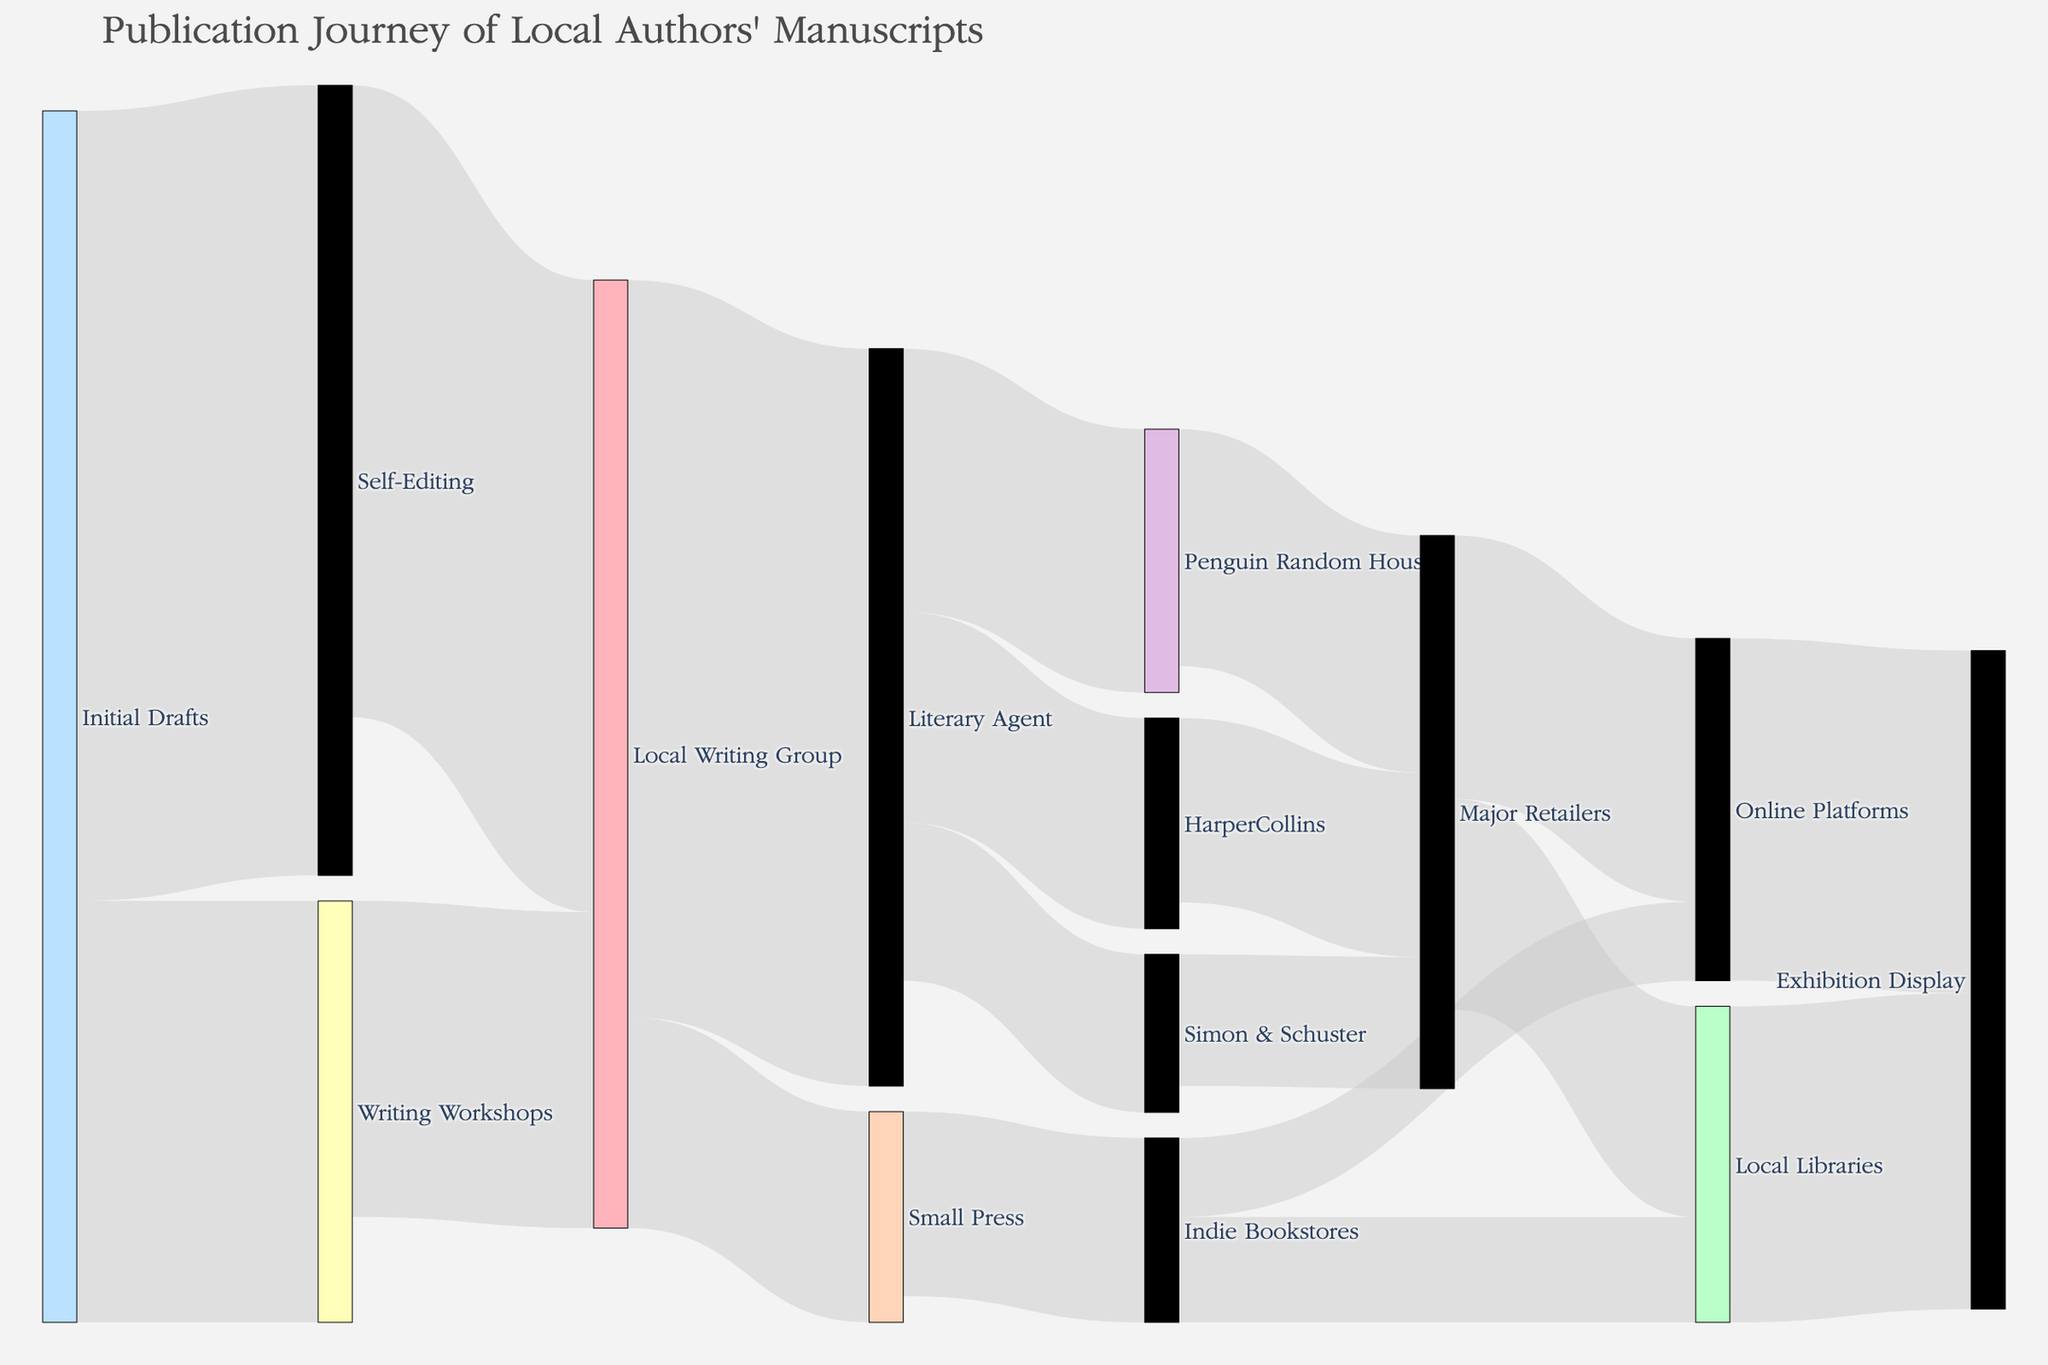What is the title of the Sankey Diagram? The title can be found at the top of the Sankey Diagram, which clearly indicates the subject of the visual representation.
Answer: Publication Journey of Local Authors' Manuscripts How many initial drafts go through self-editing? By looking at the width of the link from "Initial Drafts" to "Self-Editing" or reading the value specified in the link, you can determine this number.
Answer: 150 How many manuscripts proceed from local writing groups to literary agents? By examining the link between "Local Writing Group" and "Literary Agent," or reading the value indicated in that link.
Answer: 140 Which publishing house receives the most manuscripts from literary agents? Compare the values of the links from "Literary Agent" to different publishing houses and find the highest value.
Answer: Penguin Random House What is the total number of manuscripts that end up in major retailers? Sum up the values of the links from "Penguin Random House," "HarperCollins," and "Simon & Schuster" to "Major Retailers." The individual values are 45, 35, and 25 respectively. 45 + 35 + 25 = 105
Answer: 105 How many manuscripts are edited by local writing groups after self-editing? Look at the link value from "Self-Editing" to "Local Writing Group."
Answer: 120 Compare the number of manuscripts that go directly to a small press from local writing groups versus those that go to local libraries from indie bookstores. Which is higher? The value from "Local Writing Group" to "Small Press" is 40, while from "Indie Bookstores" to "Local Libraries" is 20.
Answer: Small Press (40) is higher What is the combined total of manuscripts that reach online platforms? Add the values of the links to "Online Platforms" from both "Indie Bookstores" and "Major Retailers." The individual values are 15 and 50. 15 + 50 = 65
Answer: 65 How many manuscripts make it from writing workshops to local writing groups? Check the value of the link connecting "Writing Workshops" to "Local Writing Group."
Answer: 60 From self-editing to exhibition display, how many steps do manuscripts typically go through? Count the individual stages along the primary path (Self-Editing -> Local Writing Group -> Literary Agent -> Publishing House -> Major Retailers -> Local Libraries -> Exhibition Display).
Answer: 6 